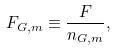<formula> <loc_0><loc_0><loc_500><loc_500>F _ { G , m } \equiv \frac { F } { n _ { G , m } } ,</formula> 